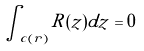<formula> <loc_0><loc_0><loc_500><loc_500>\int _ { c ( r ) } R ( z ) d z = 0</formula> 